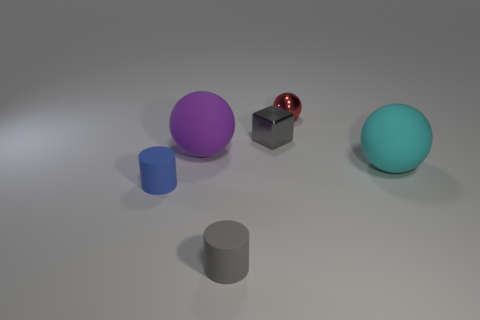Subtract all metallic spheres. How many spheres are left? 2 Add 1 big purple matte spheres. How many objects exist? 7 Subtract all cylinders. How many objects are left? 4 Subtract 1 red balls. How many objects are left? 5 Subtract all red blocks. Subtract all red spheres. How many blocks are left? 1 Subtract all tiny red metallic things. Subtract all blue rubber things. How many objects are left? 4 Add 4 tiny gray blocks. How many tiny gray blocks are left? 5 Add 6 big purple rubber things. How many big purple rubber things exist? 7 